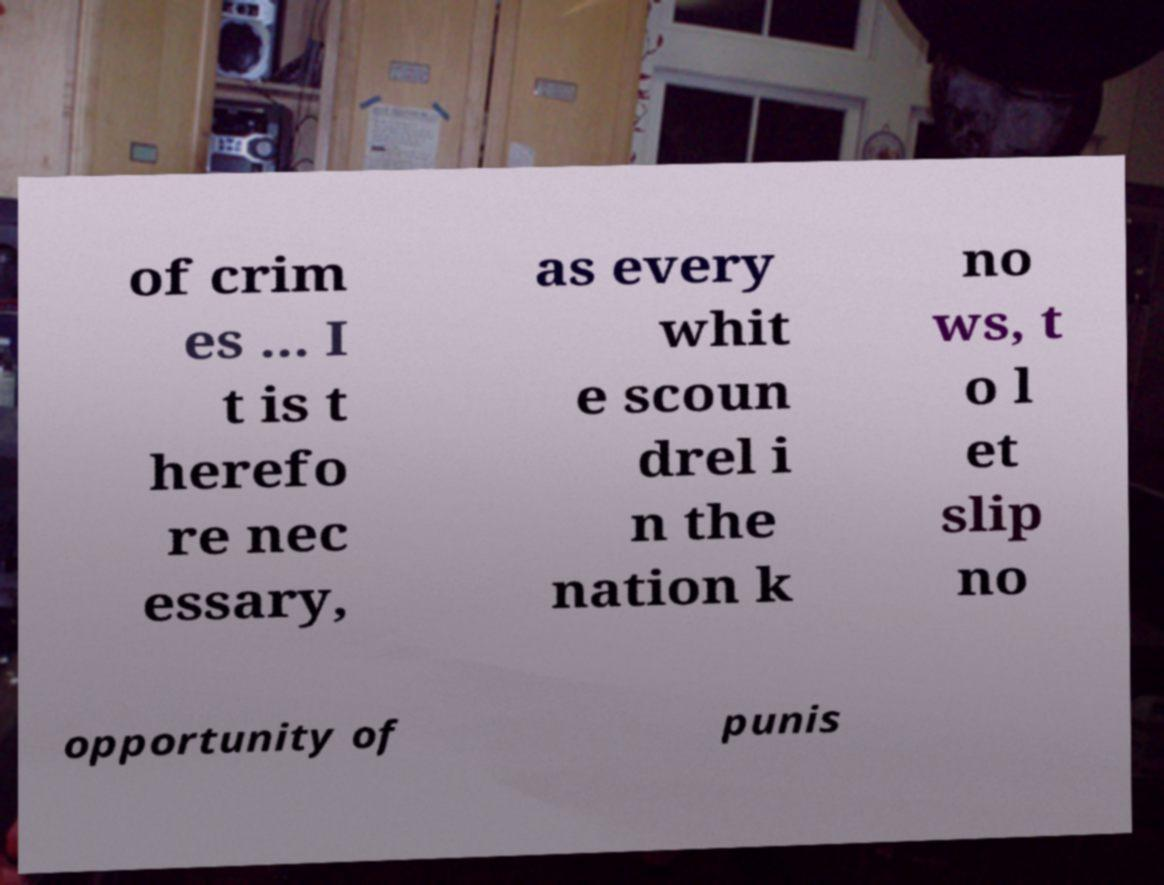What messages or text are displayed in this image? I need them in a readable, typed format. of crim es ... I t is t herefo re nec essary, as every whit e scoun drel i n the nation k no ws, t o l et slip no opportunity of punis 